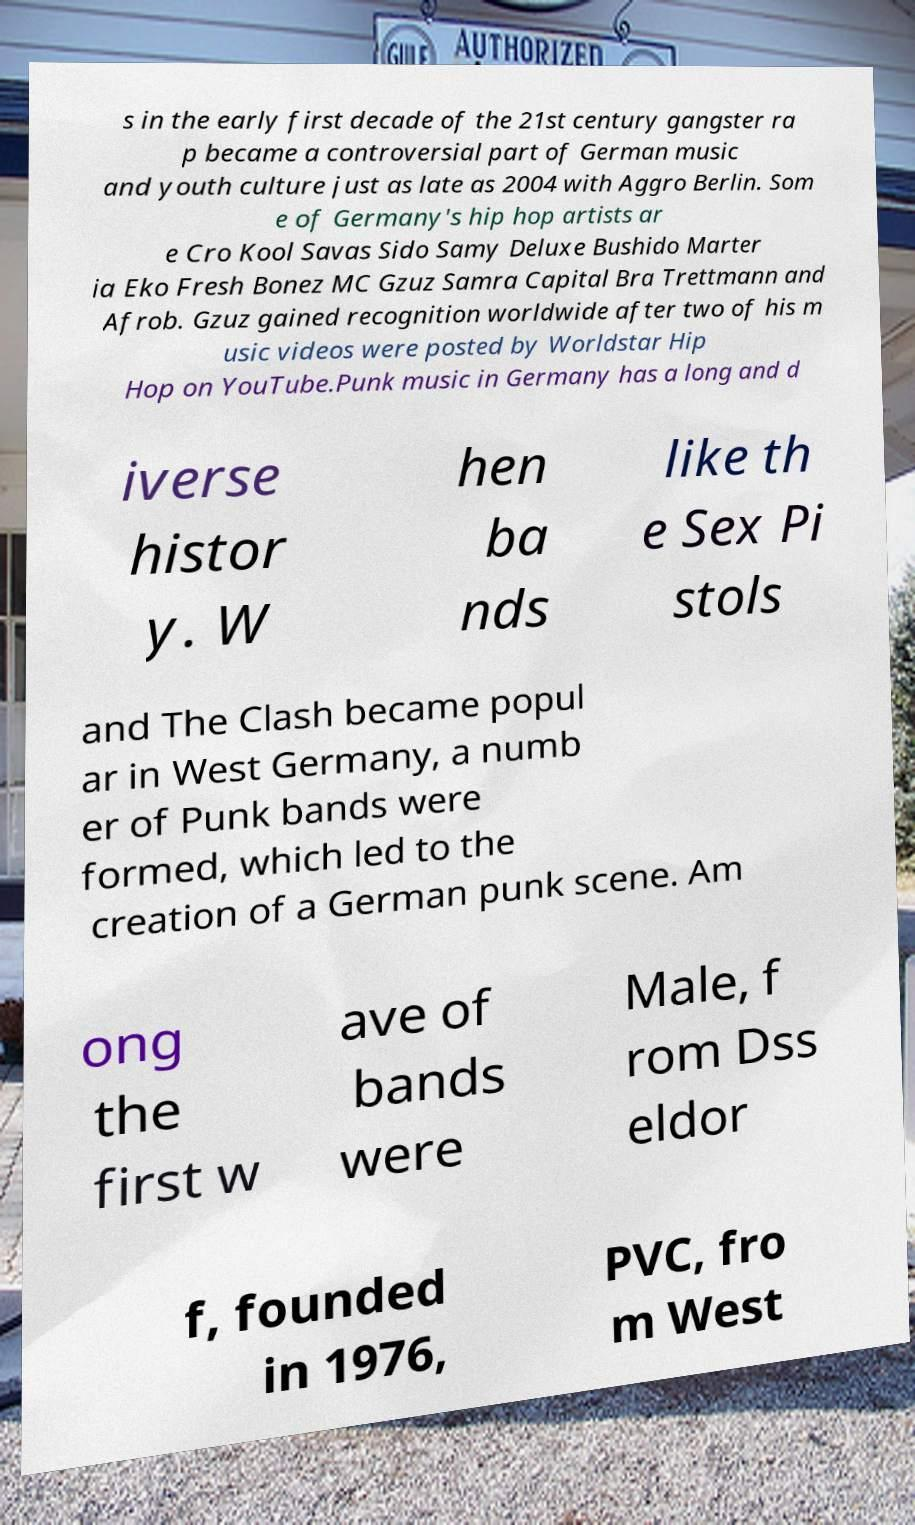Could you assist in decoding the text presented in this image and type it out clearly? s in the early first decade of the 21st century gangster ra p became a controversial part of German music and youth culture just as late as 2004 with Aggro Berlin. Som e of Germany's hip hop artists ar e Cro Kool Savas Sido Samy Deluxe Bushido Marter ia Eko Fresh Bonez MC Gzuz Samra Capital Bra Trettmann and Afrob. Gzuz gained recognition worldwide after two of his m usic videos were posted by Worldstar Hip Hop on YouTube.Punk music in Germany has a long and d iverse histor y. W hen ba nds like th e Sex Pi stols and The Clash became popul ar in West Germany, a numb er of Punk bands were formed, which led to the creation of a German punk scene. Am ong the first w ave of bands were Male, f rom Dss eldor f, founded in 1976, PVC, fro m West 